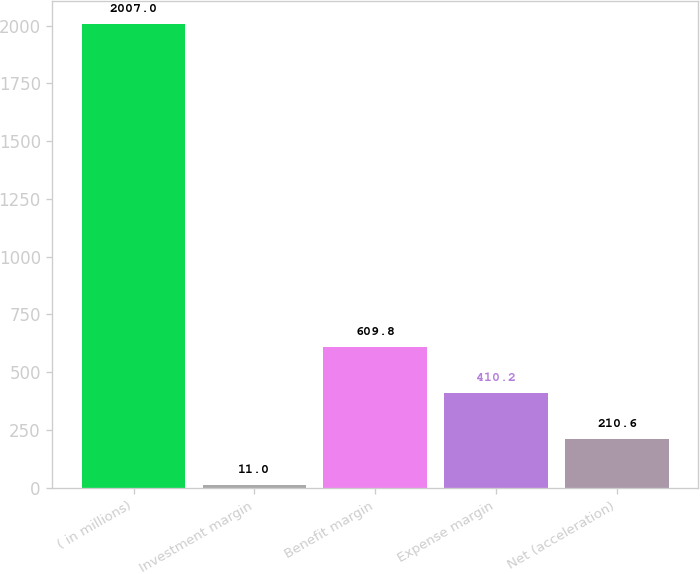Convert chart. <chart><loc_0><loc_0><loc_500><loc_500><bar_chart><fcel>( in millions)<fcel>Investment margin<fcel>Benefit margin<fcel>Expense margin<fcel>Net (acceleration)<nl><fcel>2007<fcel>11<fcel>609.8<fcel>410.2<fcel>210.6<nl></chart> 